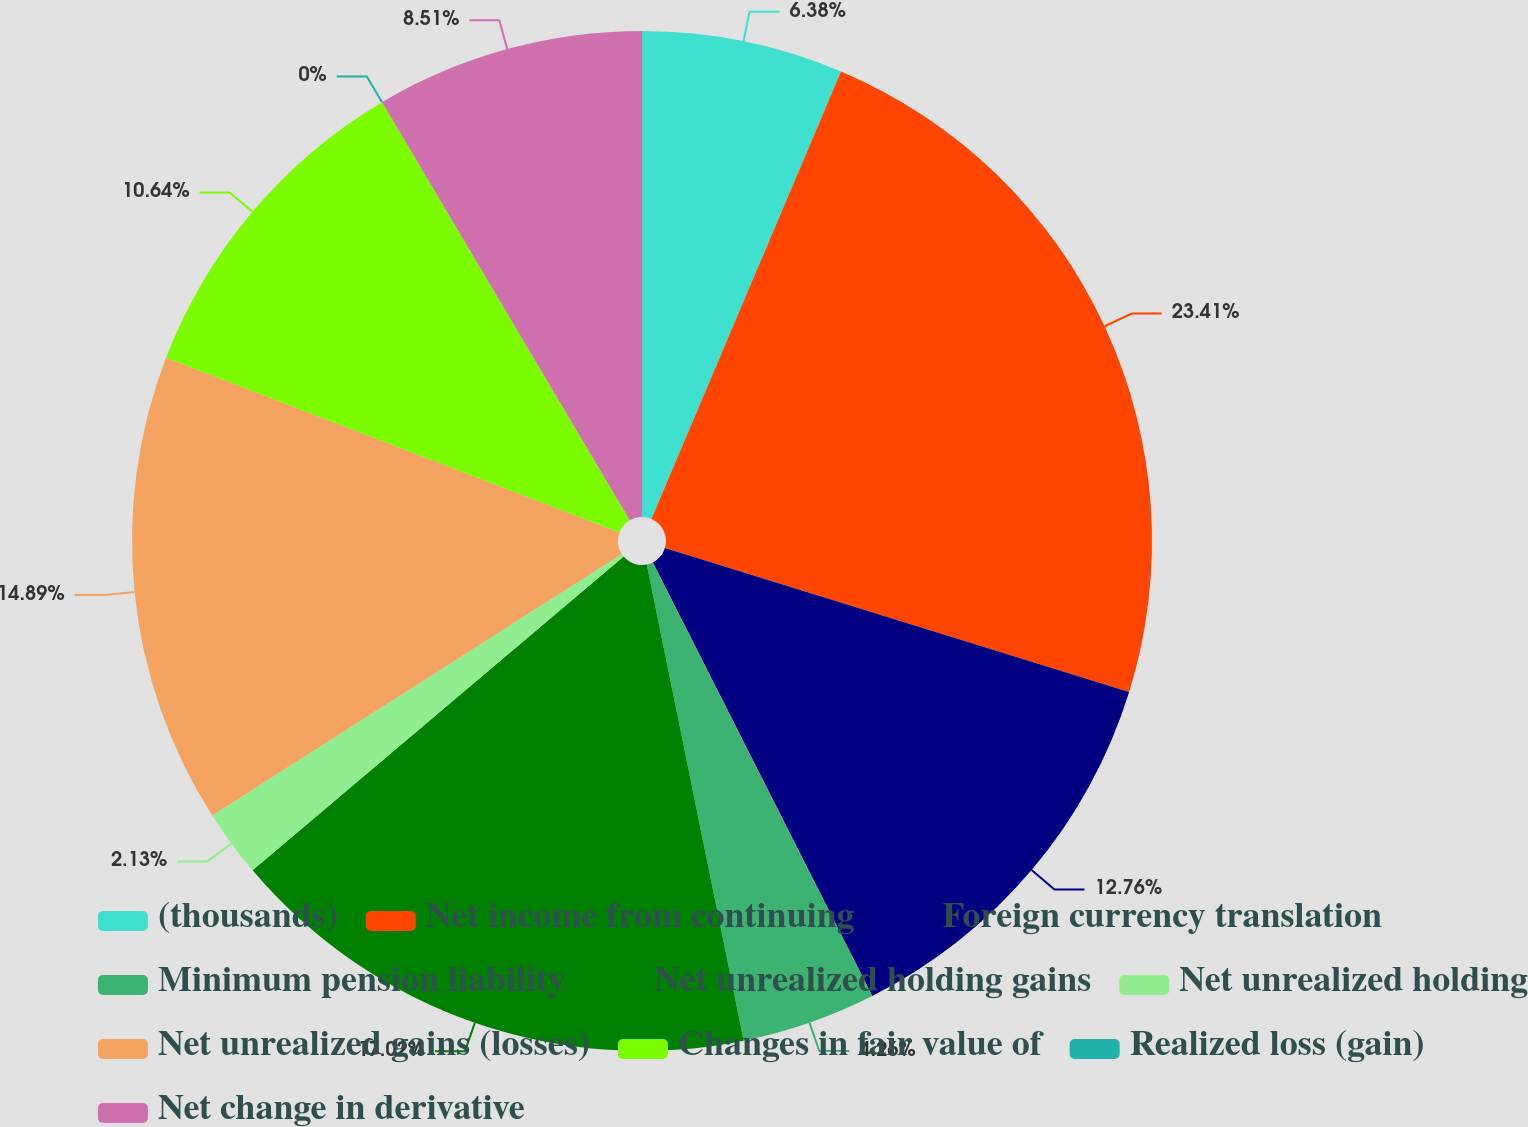Convert chart. <chart><loc_0><loc_0><loc_500><loc_500><pie_chart><fcel>(thousands)<fcel>Net income from continuing<fcel>Foreign currency translation<fcel>Minimum pension liability<fcel>Net unrealized holding gains<fcel>Net unrealized holding<fcel>Net unrealized gains (losses)<fcel>Changes in fair value of<fcel>Realized loss (gain)<fcel>Net change in derivative<nl><fcel>6.38%<fcel>23.4%<fcel>12.76%<fcel>4.26%<fcel>17.02%<fcel>2.13%<fcel>14.89%<fcel>10.64%<fcel>0.0%<fcel>8.51%<nl></chart> 